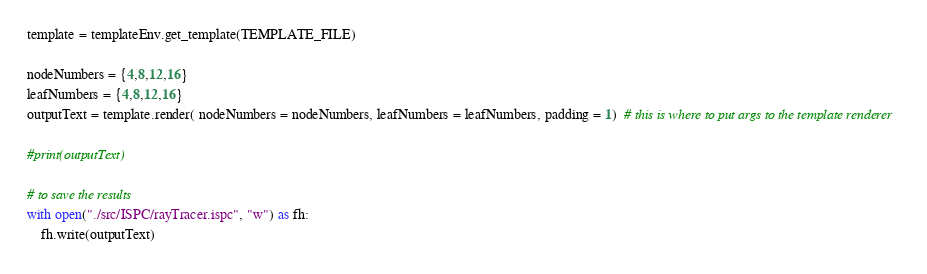<code> <loc_0><loc_0><loc_500><loc_500><_Python_>template = templateEnv.get_template(TEMPLATE_FILE)

nodeNumbers = {4,8,12,16}
leafNumbers = {4,8,12,16}
outputText = template.render( nodeNumbers = nodeNumbers, leafNumbers = leafNumbers, padding = 1)  # this is where to put args to the template renderer

#print(outputText)

# to save the results
with open("./src/ISPC/rayTracer.ispc", "w") as fh:
    fh.write(outputText)</code> 